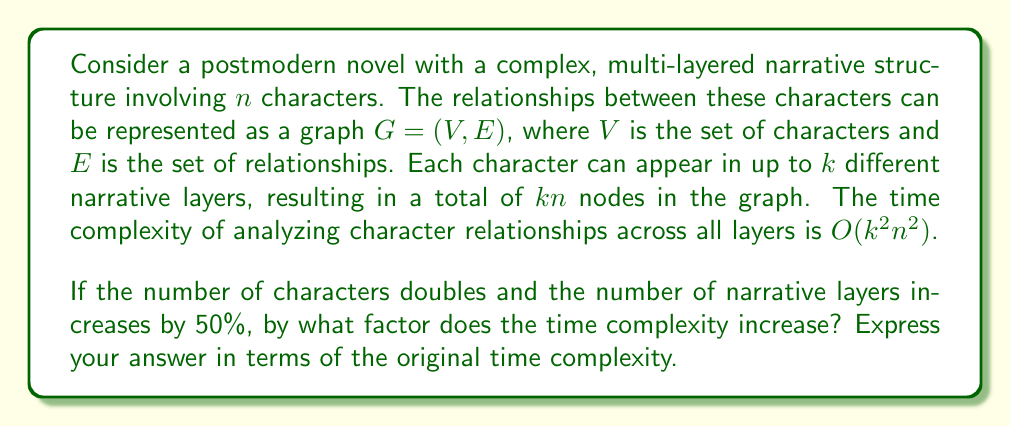Give your solution to this math problem. Let's approach this step-by-step:

1) Initially, we have:
   - $n$ characters
   - $k$ layers
   - Time complexity: $O(k^2n^2)$

2) After the changes:
   - Number of characters: $2n$
   - Number of layers: $1.5k$

3) The new time complexity will be:
   $O((1.5k)^2(2n)^2)$

4) Let's expand this:
   $O((1.5k)^2(2n)^2) = O(2.25k^2 \cdot 4n^2) = O(9k^2n^2)$

5) Now, let's compare this to the original time complexity:

   $\frac{O(9k^2n^2)}{O(k^2n^2)} = 9$

This means the new time complexity is 9 times the original time complexity.

In the context of our postmodern narrative analysis, this significant increase in complexity reflects the exponential growth in the intricacy of character relationships when both the number of characters and narrative layers increase. This mirrors the often labyrinthine nature of postmodern literature, where the multiplication of perspectives and narrative strands can lead to a dramatic expansion in the complexity of the overall narrative structure.
Answer: The time complexity increases by a factor of 9 compared to the original time complexity. 